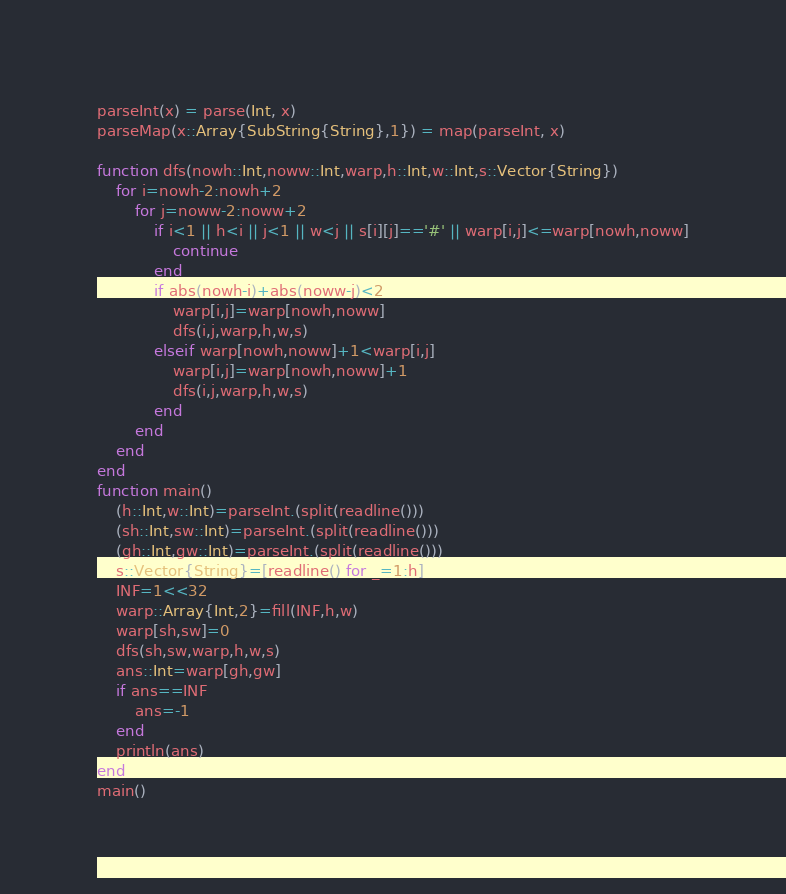Convert code to text. <code><loc_0><loc_0><loc_500><loc_500><_Julia_>parseInt(x) = parse(Int, x)
parseMap(x::Array{SubString{String},1}) = map(parseInt, x)

function dfs(nowh::Int,noww::Int,warp,h::Int,w::Int,s::Vector{String})
    for i=nowh-2:nowh+2
        for j=noww-2:noww+2
            if i<1 || h<i || j<1 || w<j || s[i][j]=='#' || warp[i,j]<=warp[nowh,noww]
                continue
            end
            if abs(nowh-i)+abs(noww-j)<2
                warp[i,j]=warp[nowh,noww]
                dfs(i,j,warp,h,w,s)
            elseif warp[nowh,noww]+1<warp[i,j]
                warp[i,j]=warp[nowh,noww]+1
                dfs(i,j,warp,h,w,s)
            end
        end
    end
end
function main()
    (h::Int,w::Int)=parseInt.(split(readline()))
    (sh::Int,sw::Int)=parseInt.(split(readline()))
    (gh::Int,gw::Int)=parseInt.(split(readline()))
    s::Vector{String}=[readline() for _=1:h]
    INF=1<<32
    warp::Array{Int,2}=fill(INF,h,w)
    warp[sh,sw]=0
    dfs(sh,sw,warp,h,w,s)
    ans::Int=warp[gh,gw]
    if ans==INF
        ans=-1
    end
    println(ans)
end
main()</code> 